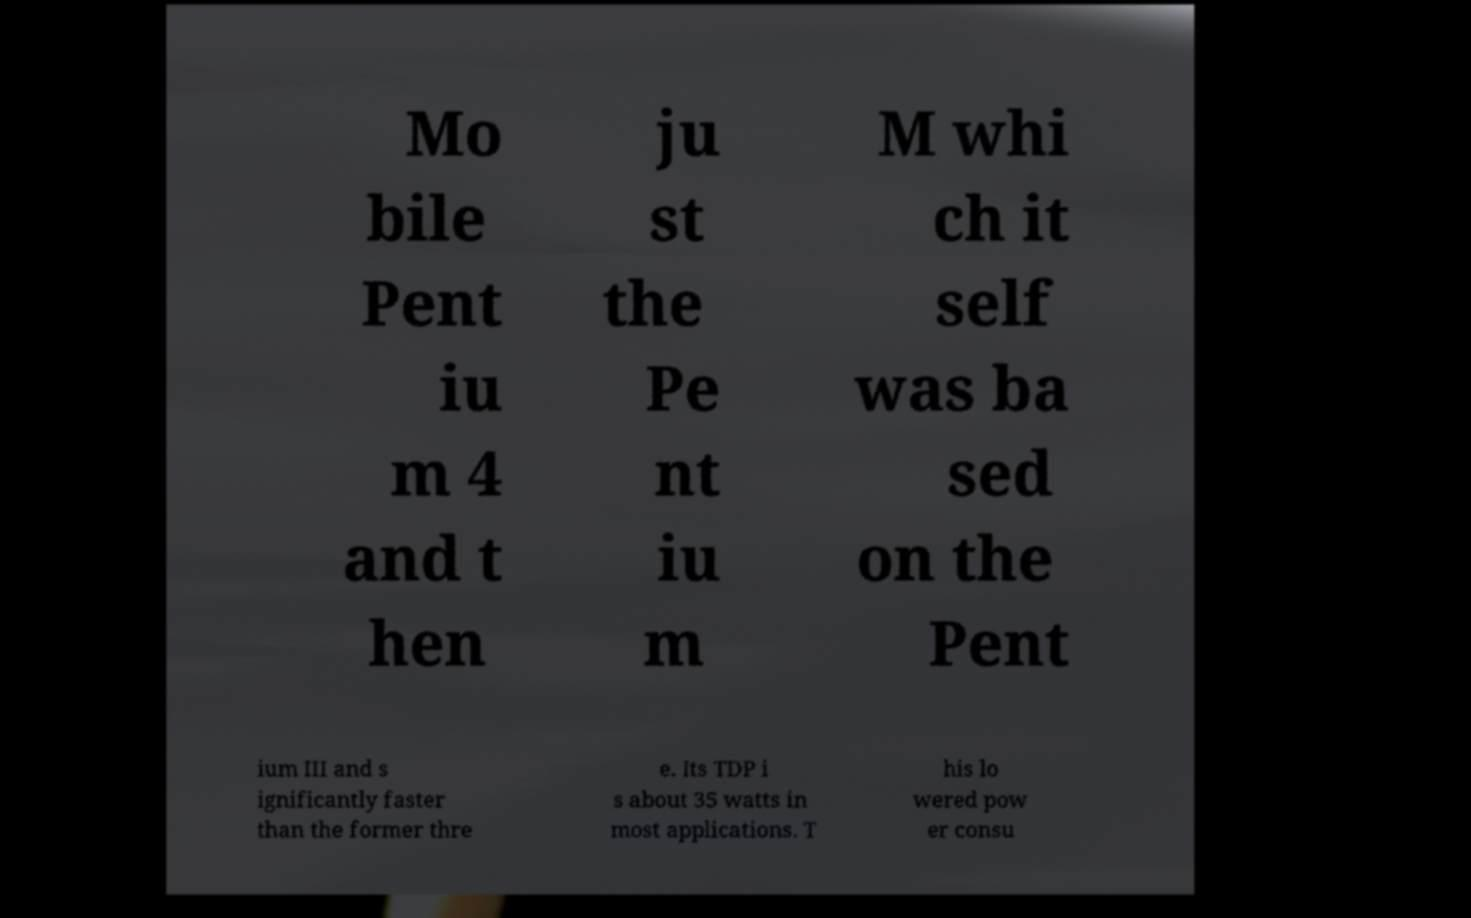Can you accurately transcribe the text from the provided image for me? Mo bile Pent iu m 4 and t hen ju st the Pe nt iu m M whi ch it self was ba sed on the Pent ium III and s ignificantly faster than the former thre e. Its TDP i s about 35 watts in most applications. T his lo wered pow er consu 